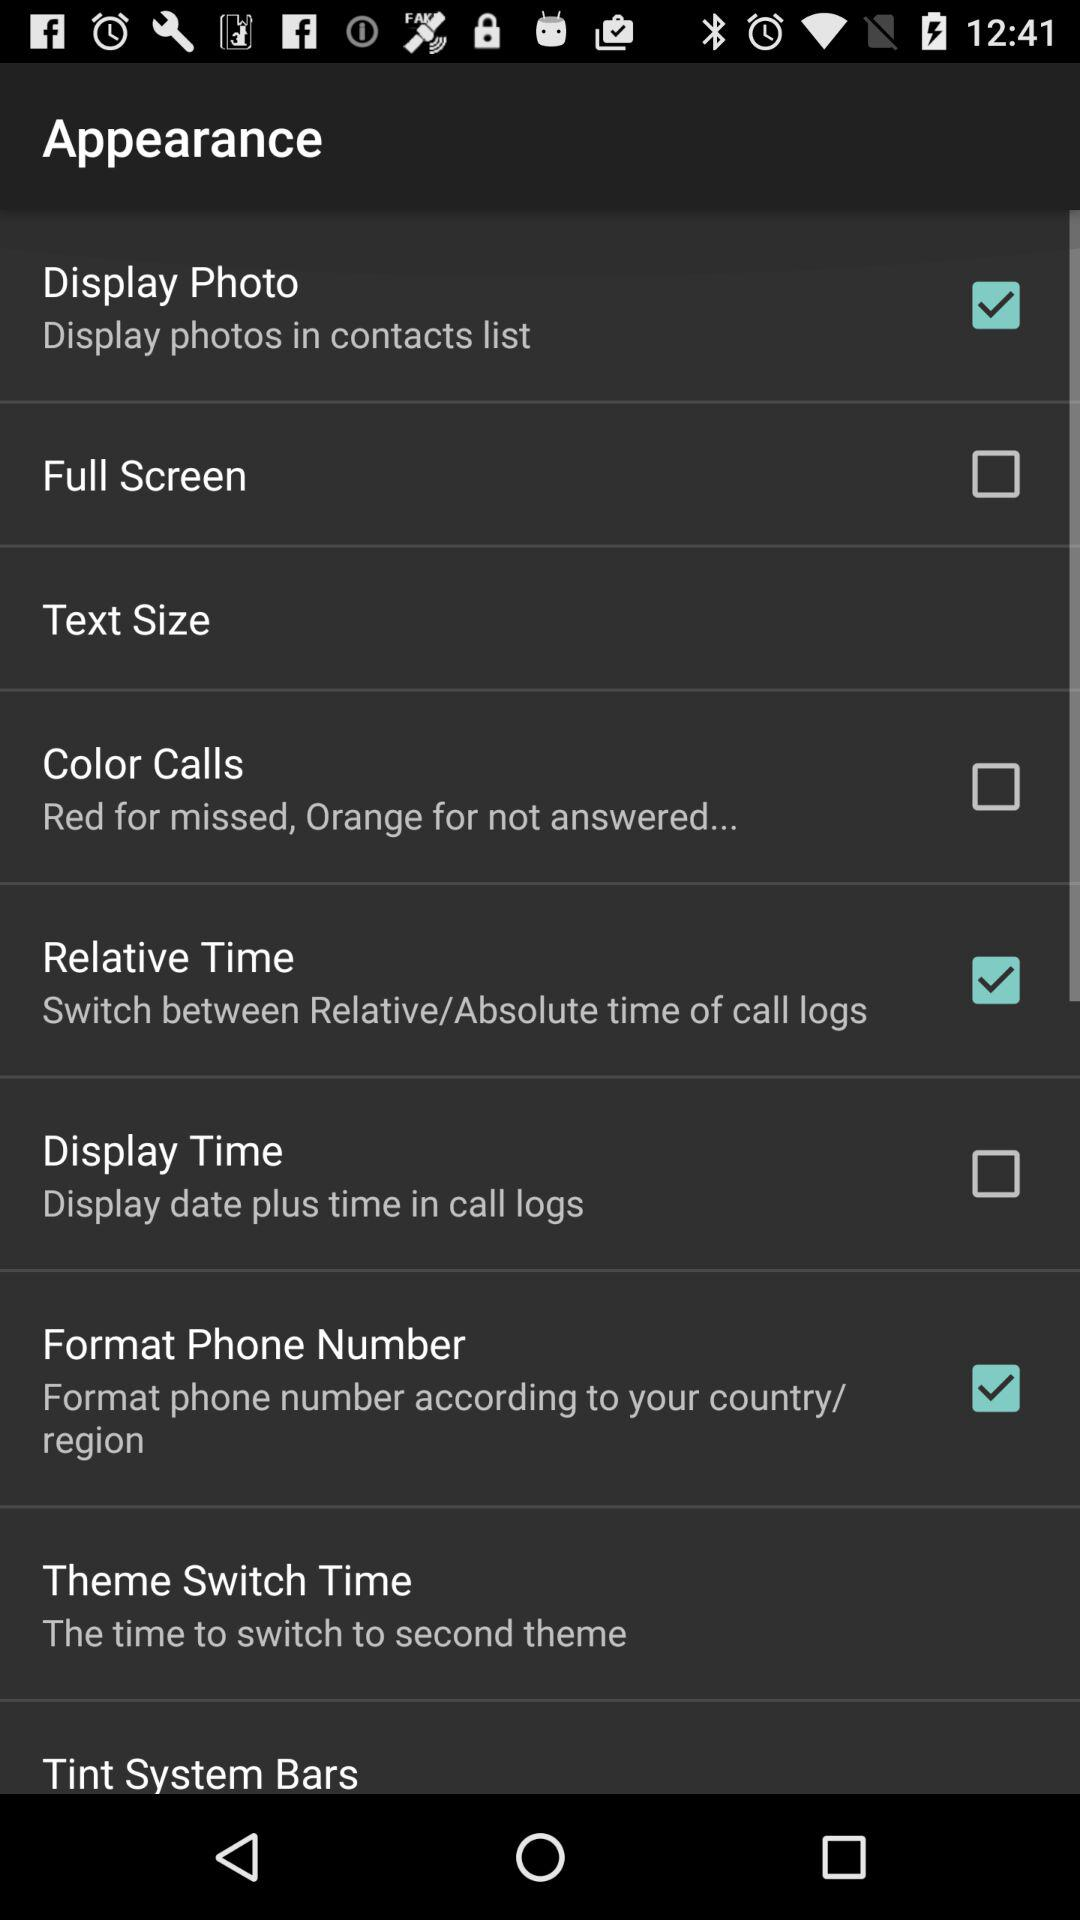What is the status of "Display Photo"? The status of "Display Photo" is "on". 